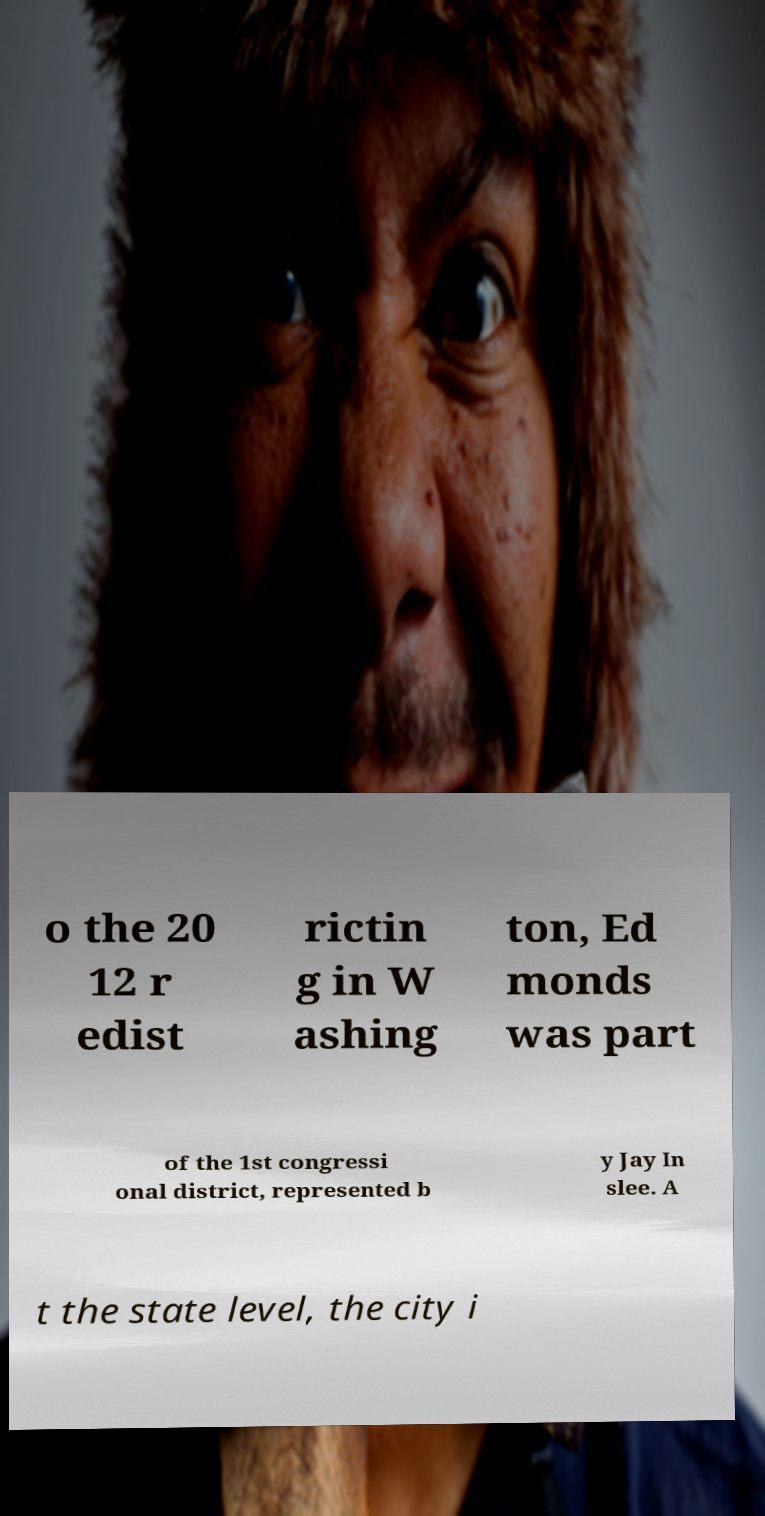There's text embedded in this image that I need extracted. Can you transcribe it verbatim? o the 20 12 r edist rictin g in W ashing ton, Ed monds was part of the 1st congressi onal district, represented b y Jay In slee. A t the state level, the city i 